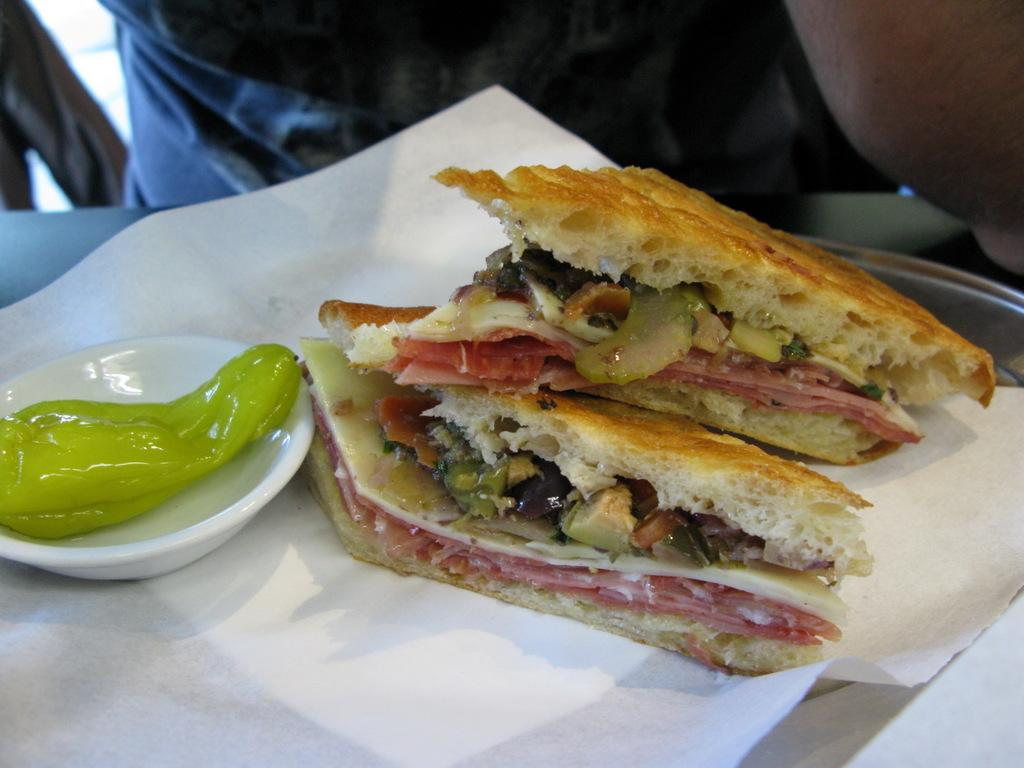What is the main subject of the image? There are two food items in the image. How are the food items arranged? The food items are in a bowl. What is the bowl placed on? The bowl is on tissue paper. Where is the tissue paper located? The tissue paper is on a tray. Can you describe the person in the background of the image? There is a person in the background of the image, but no specific details are provided. What other objects can be seen in the background of the image? There are other objects in the background of the image, but no specific details are provided. What type of seed is being planted by the person in the image? There is no person planting seeds in the image; the person is simply present in the background. 